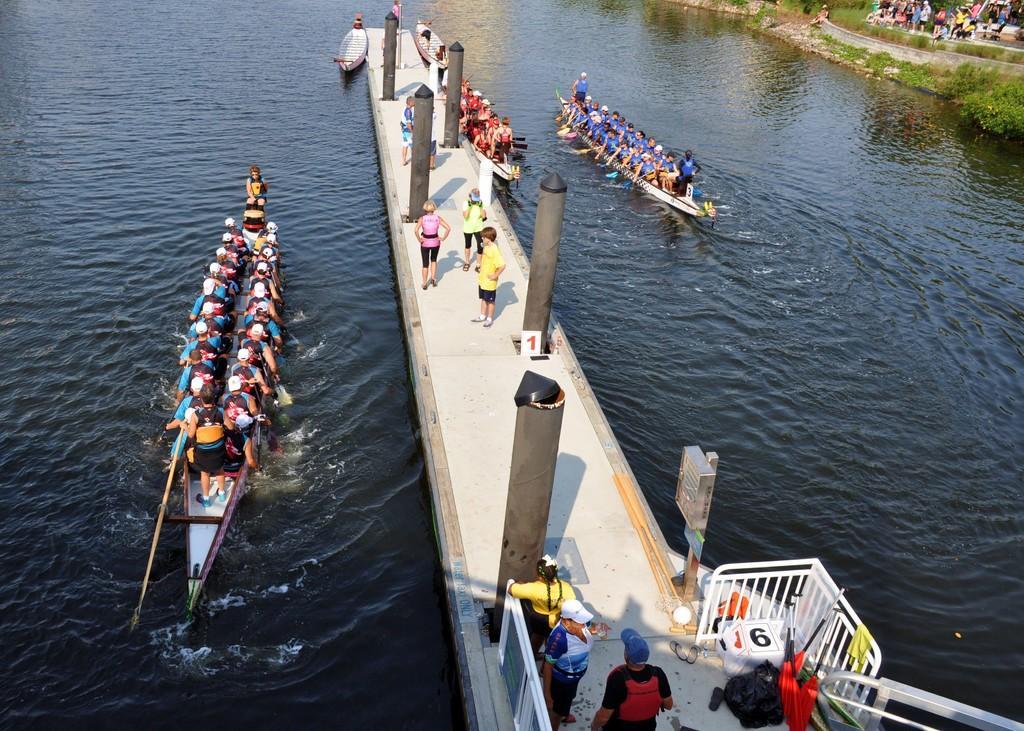Could you give a brief overview of what you see in this image? In this image we can see a group of people rowing boats on the water. In the middle of the image we can see a bridge and on the bridge we can see few pillars and persons. In the top right, we can see few plants and persons. At the top we can see two empty boats. 